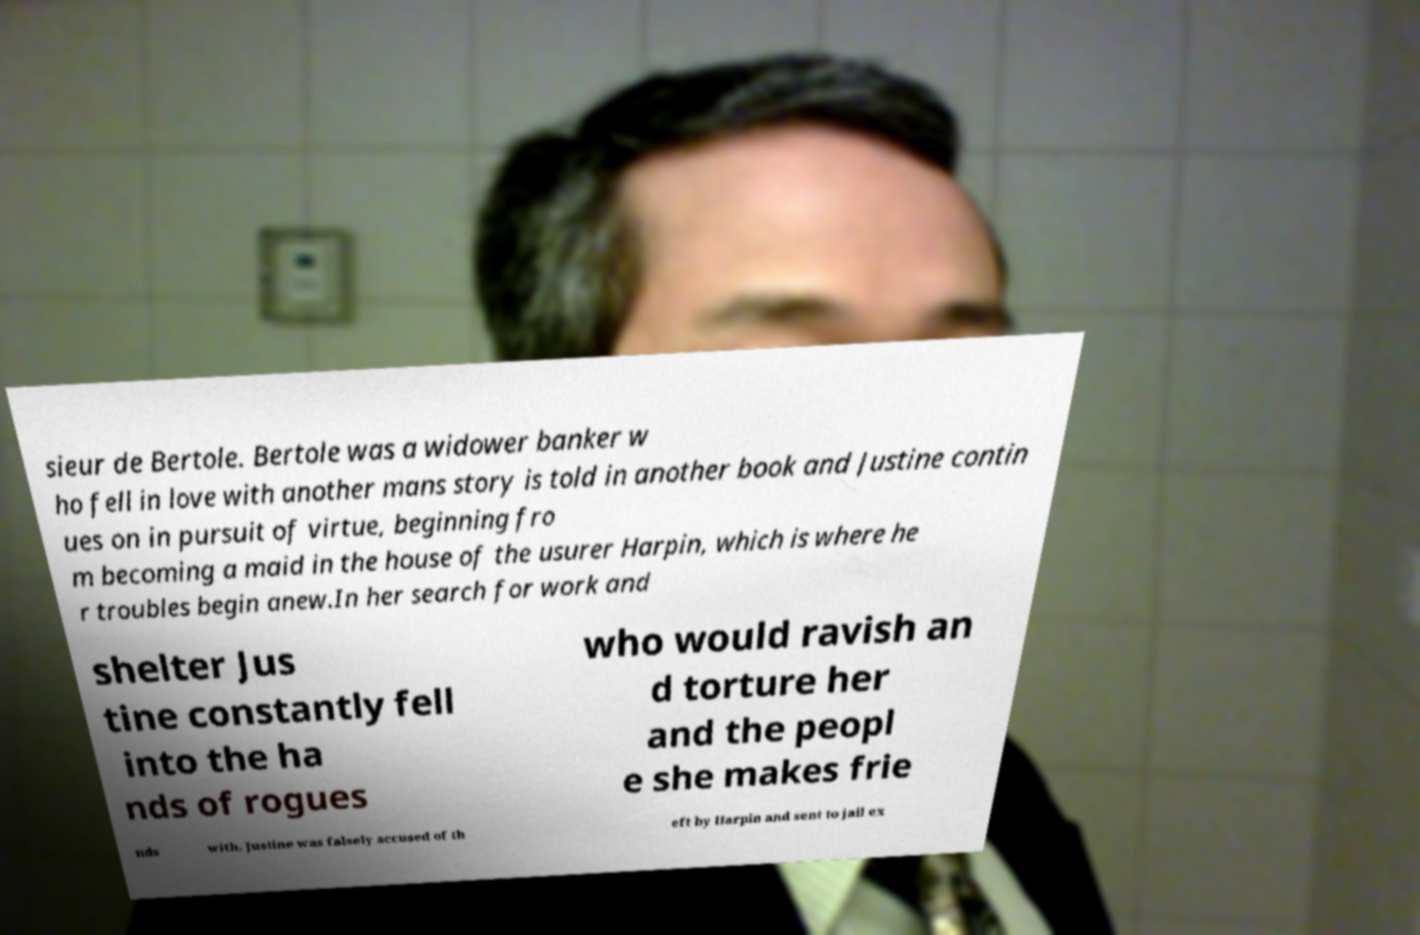Could you extract and type out the text from this image? sieur de Bertole. Bertole was a widower banker w ho fell in love with another mans story is told in another book and Justine contin ues on in pursuit of virtue, beginning fro m becoming a maid in the house of the usurer Harpin, which is where he r troubles begin anew.In her search for work and shelter Jus tine constantly fell into the ha nds of rogues who would ravish an d torture her and the peopl e she makes frie nds with. Justine was falsely accused of th eft by Harpin and sent to jail ex 